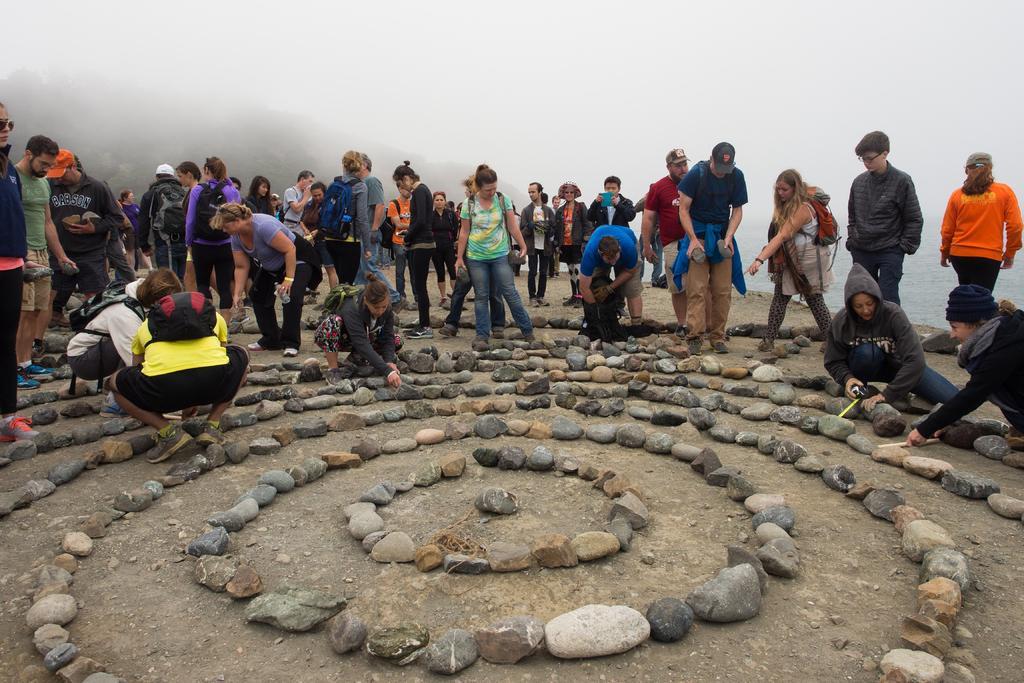Can you describe this image briefly? In the center of the image there are people. At the bottom of the image there are stones on the surface. In the background of the image there is fog. 